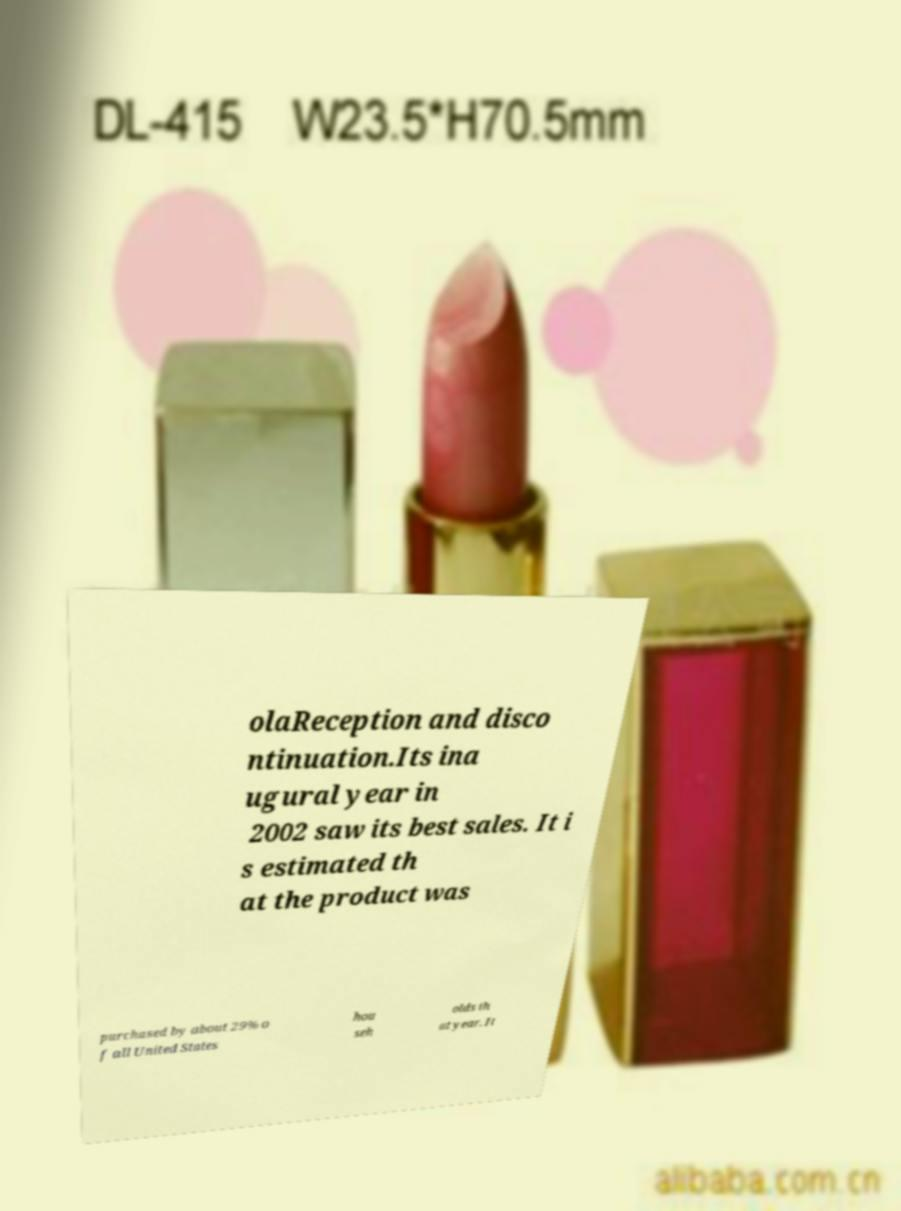For documentation purposes, I need the text within this image transcribed. Could you provide that? olaReception and disco ntinuation.Its ina ugural year in 2002 saw its best sales. It i s estimated th at the product was purchased by about 29% o f all United States hou seh olds th at year. It 